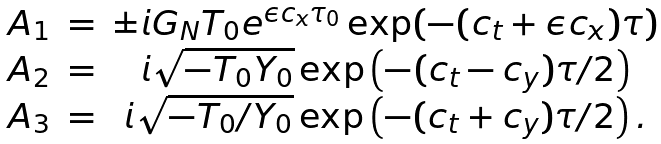<formula> <loc_0><loc_0><loc_500><loc_500>\begin{array} { c c c } A _ { 1 } & = & \pm i G _ { N } T _ { 0 } e ^ { \epsilon c _ { x } \tau _ { 0 } } \exp ( - ( c _ { t } + \epsilon c _ { x } ) \tau ) \\ A _ { 2 } & = & i \sqrt { - T _ { 0 } Y _ { 0 } } \exp \left ( - ( c _ { t } - c _ { y } ) \tau / 2 \right ) \\ A _ { 3 } & = & i \sqrt { - T _ { 0 } / Y _ { 0 } } \exp \left ( - ( c _ { t } + c _ { y } ) \tau / 2 \right ) . \end{array}</formula> 